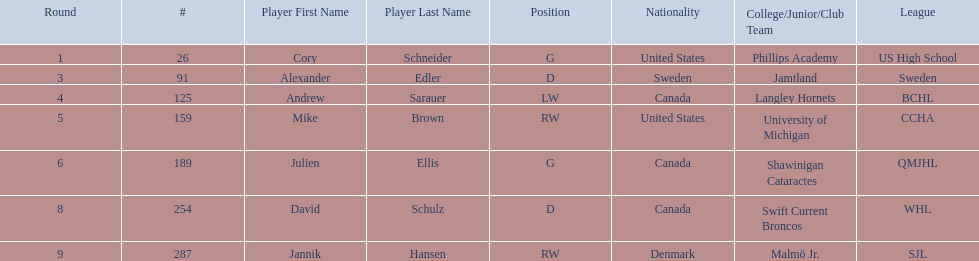Who are the players? Cory Schneider (G), Alexander Edler (D), Andrew Sarauer (LW), Mike Brown (RW), Julien Ellis (G), David Schulz (D), Jannik Hansen (RW). Of those, who is from denmark? Jannik Hansen (RW). 